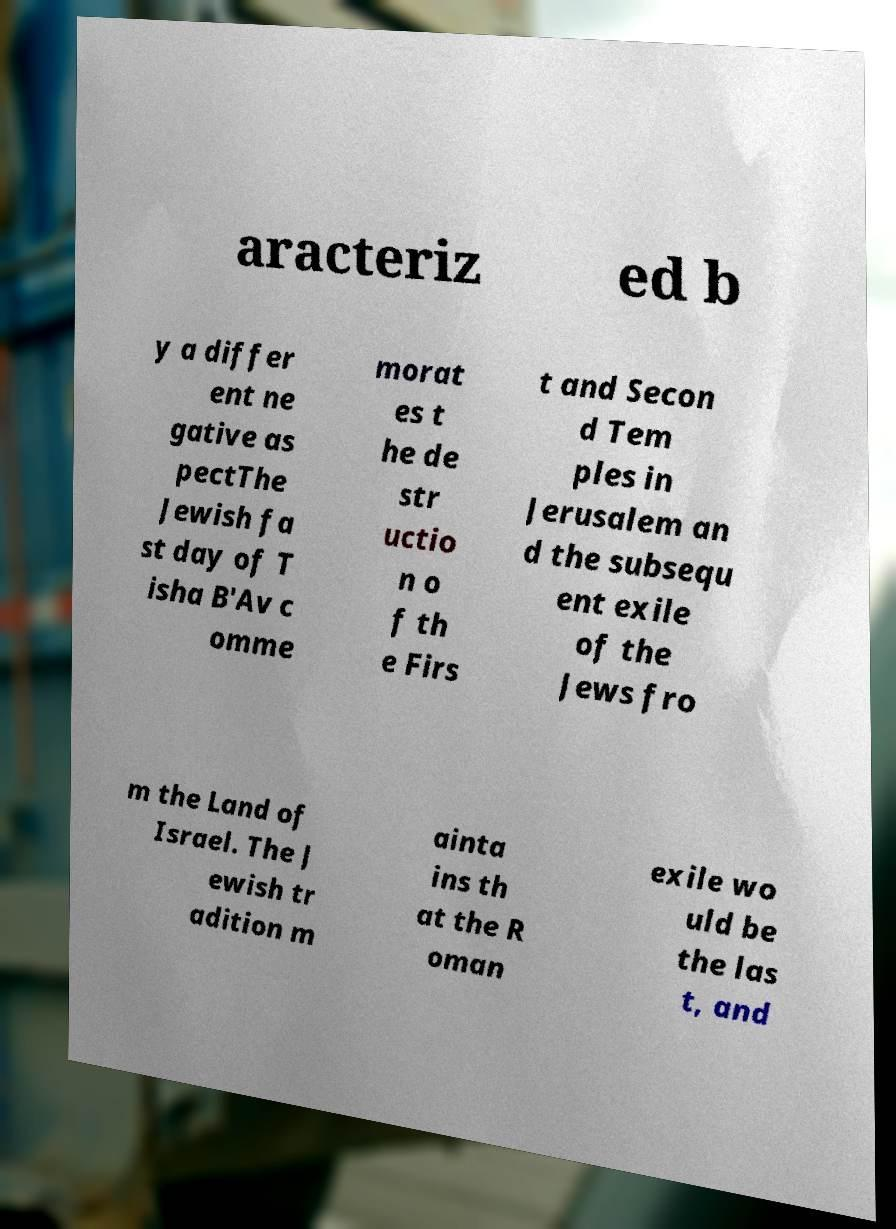What messages or text are displayed in this image? I need them in a readable, typed format. aracteriz ed b y a differ ent ne gative as pectThe Jewish fa st day of T isha B'Av c omme morat es t he de str uctio n o f th e Firs t and Secon d Tem ples in Jerusalem an d the subsequ ent exile of the Jews fro m the Land of Israel. The J ewish tr adition m ainta ins th at the R oman exile wo uld be the las t, and 